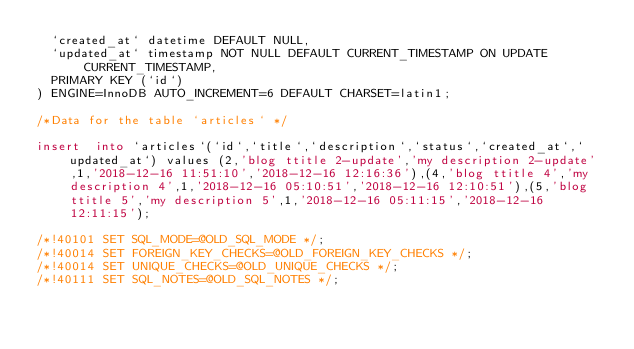Convert code to text. <code><loc_0><loc_0><loc_500><loc_500><_SQL_>  `created_at` datetime DEFAULT NULL,
  `updated_at` timestamp NOT NULL DEFAULT CURRENT_TIMESTAMP ON UPDATE CURRENT_TIMESTAMP,
  PRIMARY KEY (`id`)
) ENGINE=InnoDB AUTO_INCREMENT=6 DEFAULT CHARSET=latin1;

/*Data for the table `articles` */

insert  into `articles`(`id`,`title`,`description`,`status`,`created_at`,`updated_at`) values (2,'blog ttitle 2-update','my description 2-update',1,'2018-12-16 11:51:10','2018-12-16 12:16:36'),(4,'blog ttitle 4','my description 4',1,'2018-12-16 05:10:51','2018-12-16 12:10:51'),(5,'blog ttitle 5','my description 5',1,'2018-12-16 05:11:15','2018-12-16 12:11:15');

/*!40101 SET SQL_MODE=@OLD_SQL_MODE */;
/*!40014 SET FOREIGN_KEY_CHECKS=@OLD_FOREIGN_KEY_CHECKS */;
/*!40014 SET UNIQUE_CHECKS=@OLD_UNIQUE_CHECKS */;
/*!40111 SET SQL_NOTES=@OLD_SQL_NOTES */;
</code> 